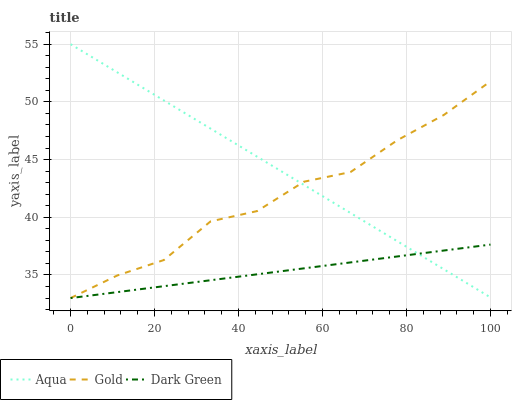Does Dark Green have the minimum area under the curve?
Answer yes or no. Yes. Does Aqua have the maximum area under the curve?
Answer yes or no. Yes. Does Gold have the minimum area under the curve?
Answer yes or no. No. Does Gold have the maximum area under the curve?
Answer yes or no. No. Is Aqua the smoothest?
Answer yes or no. Yes. Is Gold the roughest?
Answer yes or no. Yes. Is Dark Green the smoothest?
Answer yes or no. No. Is Dark Green the roughest?
Answer yes or no. No. Does Gold have the lowest value?
Answer yes or no. Yes. Does Aqua have the highest value?
Answer yes or no. Yes. Does Gold have the highest value?
Answer yes or no. No. Does Dark Green intersect Aqua?
Answer yes or no. Yes. Is Dark Green less than Aqua?
Answer yes or no. No. Is Dark Green greater than Aqua?
Answer yes or no. No. 